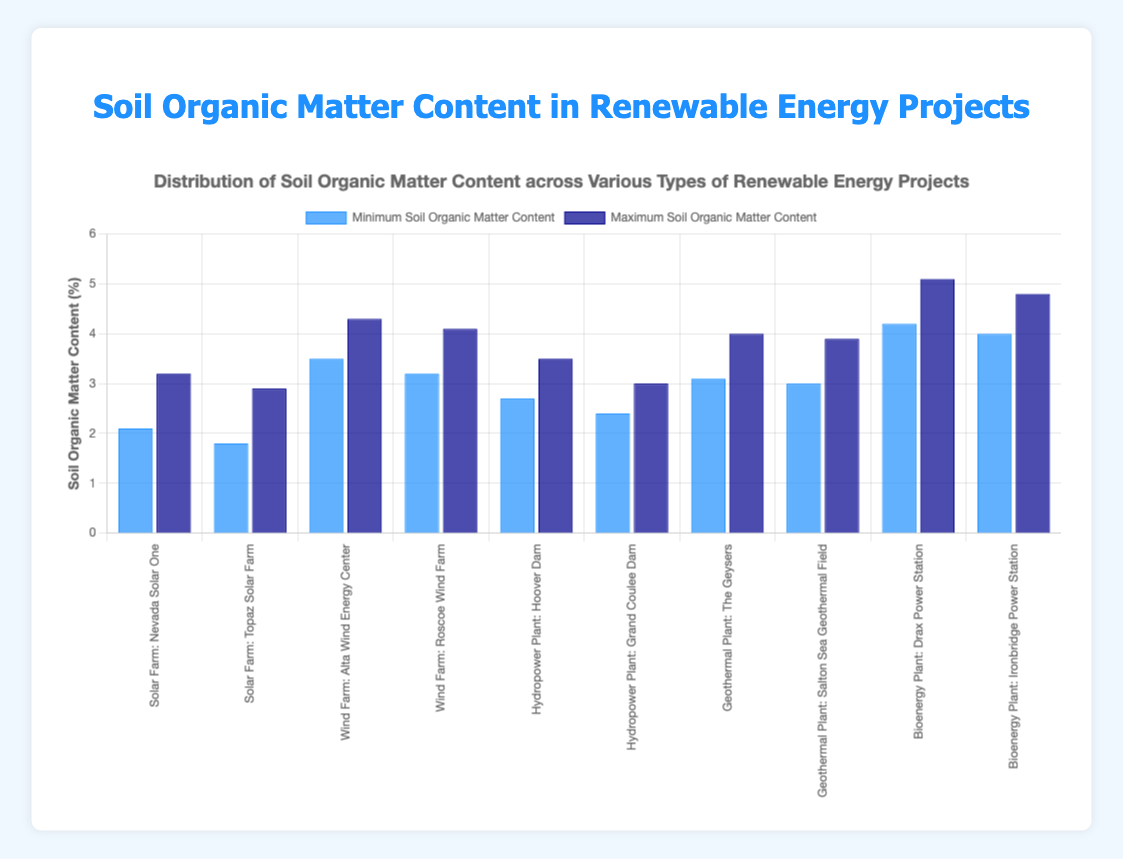What type of renewable energy project has the highest average soil organic matter content across all locations? By looking at the average soil organic matter content values for each project type, Bioenergy Plants have the highest average values: Drax Power Station with 4.6 and Ironbridge Power Station with 4.4, both higher than any other projects.
Answer: Bioenergy Plant Which project has the lowest minimum soil organic matter content among all locations? Comparing the minimum soil organic matter content values for all projects, Topaz Solar Farm has the lowest at 1.8.
Answer: Topaz Solar Farm How does the maximum soil organic matter content at Nevada Solar One compare to that at Hoover Dam? The maximum soil organic matter content at Nevada Solar One is 3.2, while at Hoover Dam it is 3.5. Therefore, Hoover Dam has a higher maximum soil organic matter content.
Answer: Nevada Solar One < Hoover Dam Calculate the difference between the maximum soil organic matter content and the minimum soil organic matter content for the Roscoe Wind Farm. Subtracting the minimum value (3.2) from the maximum value (4.1), you get 4.1 - 3.2 = 0.9.
Answer: 0.9 Which locations have exactly the same minimum soil organic matter content, and what is that value? Both Salton Sea Geothermal Field and The Geysers have a minimum value of 3.0, as shown by their data points.
Answer: Salton Sea Geothermal Field and The Geysers, 3.0 What's the average maximum soil organic matter content for all Bioenergy Plant locations combined? The maximum values for Drax Power Station and Ironbridge Power Station are 5.1 and 4.8, respectively. The average is calculated as (5.1 + 4.8) / 2 = 4.95.
Answer: 4.95 Which project type has a greater range of soil organic matter content: Wind Farm or Hydropower Plant? The Wind Farm has ranges of 3.5-4.3 and 3.2-4.1 for Alta Wind Energy Center and Roscoe Wind Farm, respectively. The Hydropower Plant has ranges of 2.7-3.5 and 2.4-3.0 for Hoover Dam and Grand Coulee Dam. The ranges are 0.8, 0.9 for Wind Farm and 0.8, 0.6 for Hydropower Plant. Therefore, Wind Farm has a larger range.
Answer: Wind Farm How does the visual height of the maximum soil organic matter content bar for the Drax Power Station compare to other projects? The height of the bar for Drax Power Station (5.1) is visually the tallest, indicating the highest soil organic matter content among all projects.
Answer: Tallest 